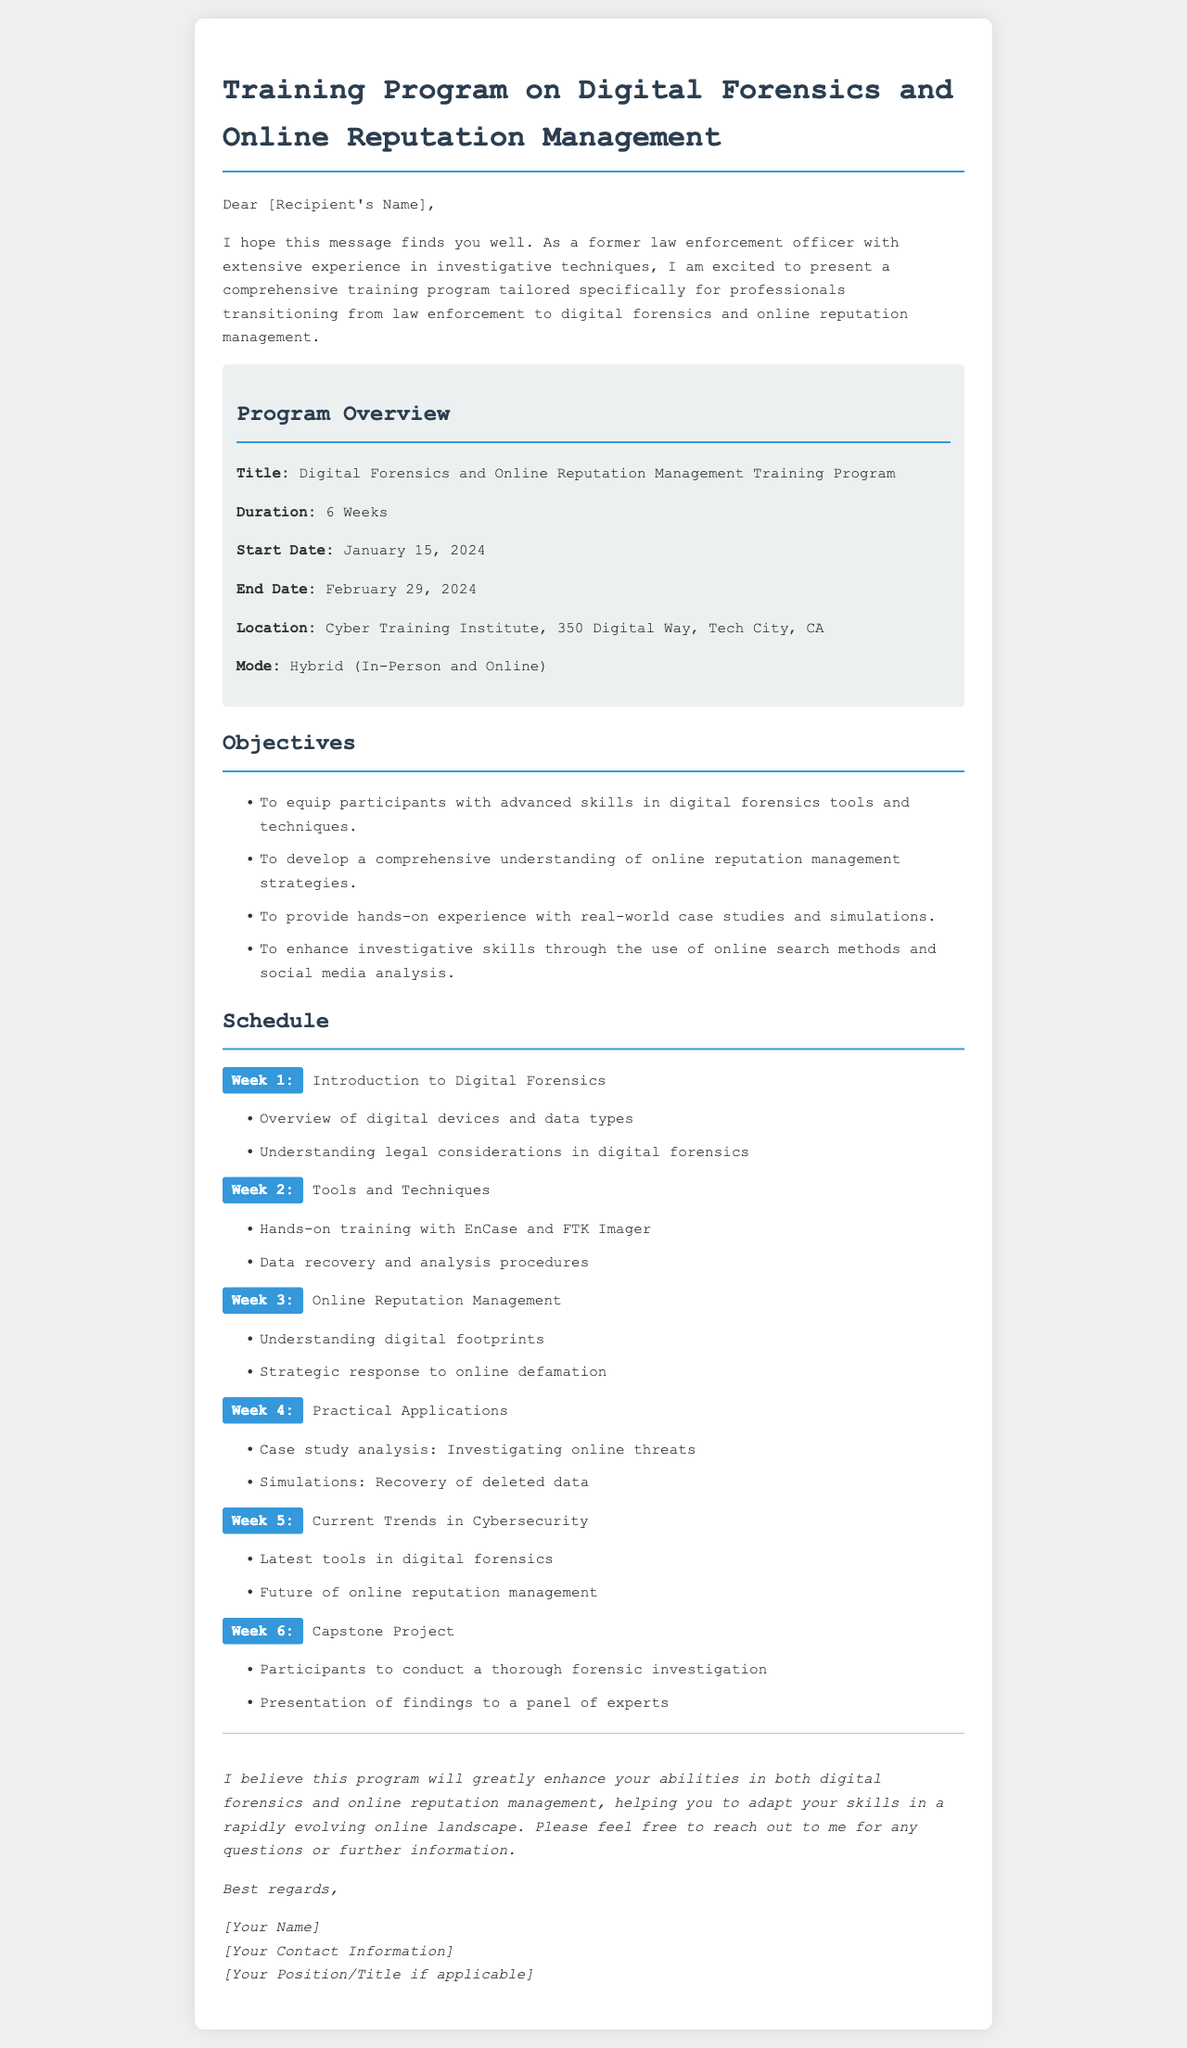What is the title of the training program? The title of the training program is located in the program overview section.
Answer: Digital Forensics and Online Reputation Management Training Program What is the duration of the training program? The duration is specified in the program overview section.
Answer: 6 Weeks When does the training program start? The start date is mentioned in the program overview section.
Answer: January 15, 2024 What is one objective of the program? Objectives are listed in the objectives section; one can be chosen for this question.
Answer: To equip participants with advanced skills in digital forensics tools and techniques Which week focuses on Online Reputation Management? The week is indicated in the schedule section.
Answer: Week 3 What is the location of the training program? The location is provided in the program overview section.
Answer: Cyber Training Institute, 350 Digital Way, Tech City, CA What type of project do participants complete in Week 6? The type of project is described in the schedule section for Week 6.
Answer: Capstone Project What is the mode of delivery for the program? The mode is described in the program overview section.
Answer: Hybrid (In-Person and Online) 